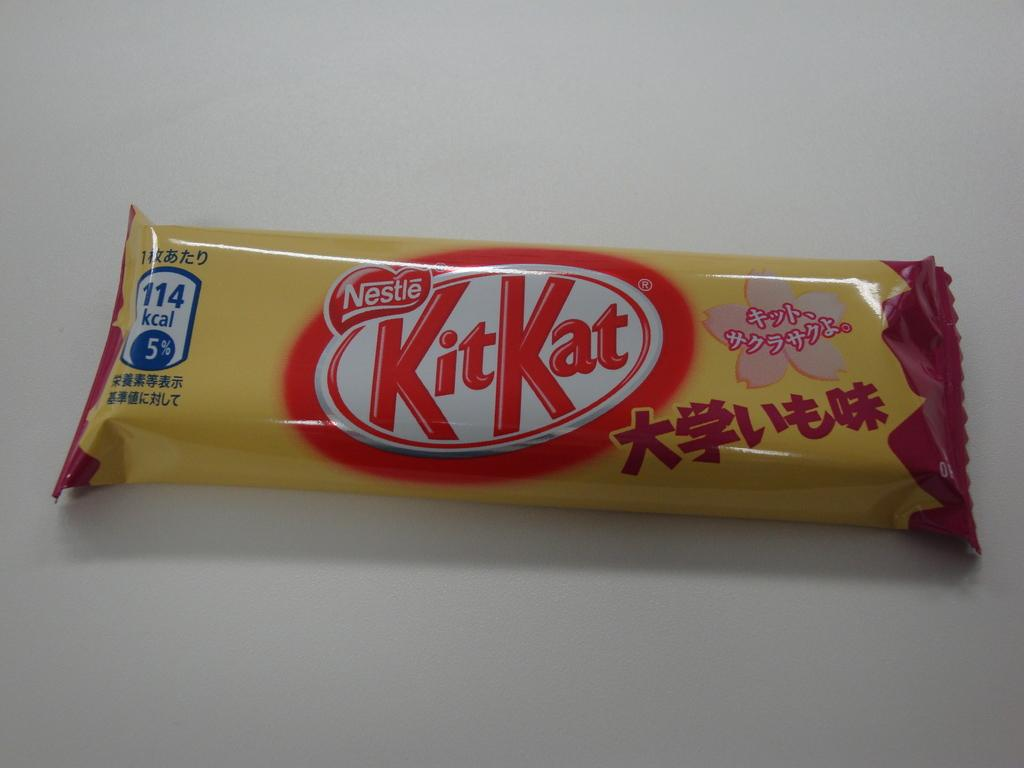What is the main object in the image? There is a food packet in the image. What information is present on the food packet? There are numbers and text on the food packet. What can be seen in the background of the image? There is a floor visible in the background of the image. How many rings does the person in the image have on their fingers? There is no person present in the image, so it is not possible to determine the number of rings they might be wearing. 